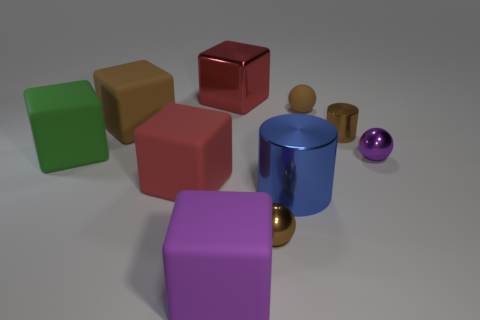Subtract all tiny shiny balls. How many balls are left? 1 Subtract all green cubes. How many brown spheres are left? 2 Subtract all green cubes. How many cubes are left? 4 Subtract all balls. How many objects are left? 7 Subtract 1 cylinders. How many cylinders are left? 1 Subtract all yellow spheres. Subtract all yellow cylinders. How many spheres are left? 3 Add 3 red balls. How many red balls exist? 3 Subtract 0 yellow cubes. How many objects are left? 10 Subtract all small gray shiny things. Subtract all green cubes. How many objects are left? 9 Add 3 tiny purple metal balls. How many tiny purple metal balls are left? 4 